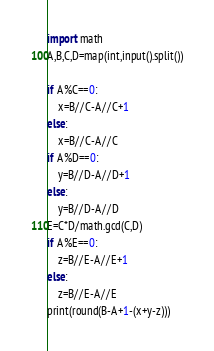Convert code to text. <code><loc_0><loc_0><loc_500><loc_500><_Python_>import math
A,B,C,D=map(int,input().split())

if A%C==0:
    x=B//C-A//C+1
else:
    x=B//C-A//C
if A%D==0:
    y=B//D-A//D+1
else:
    y=B//D-A//D
E=C*D/math.gcd(C,D)
if A%E==0:
    z=B//E-A//E+1
else:
    z=B//E-A//E
print(round(B-A+1-(x+y-z)))
</code> 